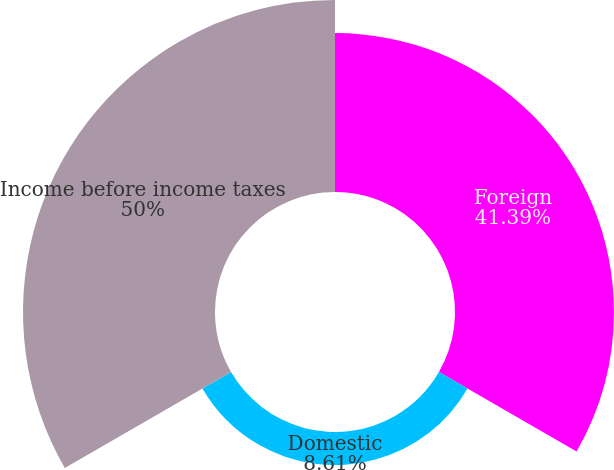<chart> <loc_0><loc_0><loc_500><loc_500><pie_chart><fcel>Foreign<fcel>Domestic<fcel>Income before income taxes<nl><fcel>41.39%<fcel>8.61%<fcel>50.0%<nl></chart> 